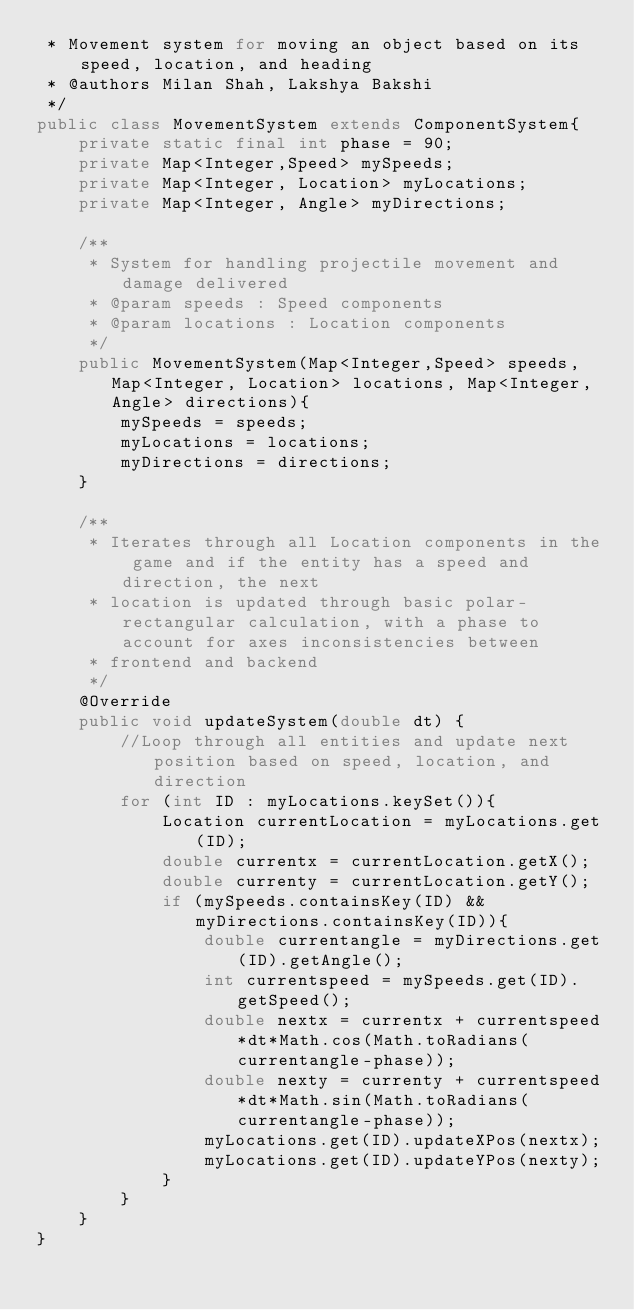<code> <loc_0><loc_0><loc_500><loc_500><_Java_> * Movement system for moving an object based on its speed, location, and heading
 * @authors Milan Shah, Lakshya Bakshi
 */
public class MovementSystem extends ComponentSystem{
    private static final int phase = 90;
    private Map<Integer,Speed> mySpeeds;
    private Map<Integer, Location> myLocations;
    private Map<Integer, Angle> myDirections;

    /**
     * System for handling projectile movement and damage delivered
     * @param speeds : Speed components
     * @param locations : Location components
     */
    public MovementSystem(Map<Integer,Speed> speeds, Map<Integer, Location> locations, Map<Integer, Angle> directions){
        mySpeeds = speeds;
        myLocations = locations;
        myDirections = directions;
    }

    /**
     * Iterates through all Location components in the game and if the entity has a speed and direction, the next
     * location is updated through basic polar-rectangular calculation, with a phase to account for axes inconsistencies between
     * frontend and backend
     */
    @Override
    public void updateSystem(double dt) {
        //Loop through all entities and update next position based on speed, location, and direction
        for (int ID : myLocations.keySet()){
            Location currentLocation = myLocations.get(ID);
            double currentx = currentLocation.getX();
            double currenty = currentLocation.getY();
            if (mySpeeds.containsKey(ID) && myDirections.containsKey(ID)){
                double currentangle = myDirections.get(ID).getAngle();
                int currentspeed = mySpeeds.get(ID).getSpeed();
                double nextx = currentx + currentspeed*dt*Math.cos(Math.toRadians(currentangle-phase));
                double nexty = currenty + currentspeed*dt*Math.sin(Math.toRadians(currentangle-phase));
                myLocations.get(ID).updateXPos(nextx);
                myLocations.get(ID).updateYPos(nexty);
            }
        }
    }
}
</code> 